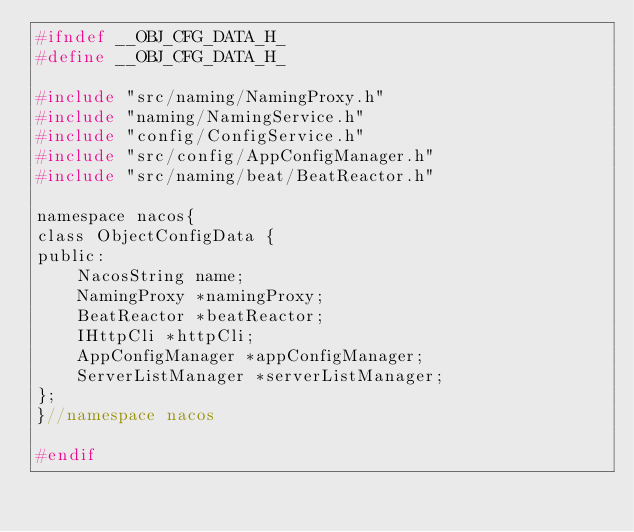<code> <loc_0><loc_0><loc_500><loc_500><_C_>#ifndef __OBJ_CFG_DATA_H_
#define __OBJ_CFG_DATA_H_

#include "src/naming/NamingProxy.h"
#include "naming/NamingService.h"
#include "config/ConfigService.h"
#include "src/config/AppConfigManager.h"
#include "src/naming/beat/BeatReactor.h"

namespace nacos{
class ObjectConfigData {
public:
    NacosString name;
    NamingProxy *namingProxy;
    BeatReactor *beatReactor;
    IHttpCli *httpCli;
    AppConfigManager *appConfigManager;
    ServerListManager *serverListManager;
};
}//namespace nacos

#endif</code> 